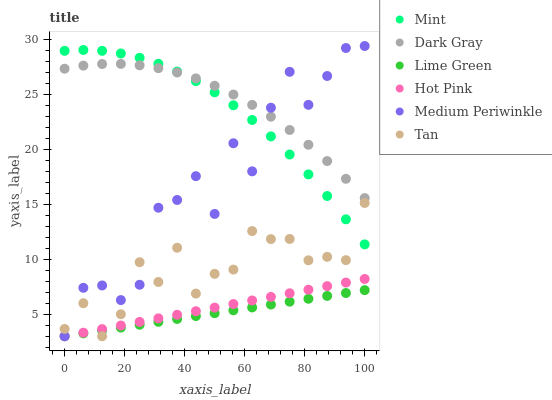Does Lime Green have the minimum area under the curve?
Answer yes or no. Yes. Does Dark Gray have the maximum area under the curve?
Answer yes or no. Yes. Does Hot Pink have the minimum area under the curve?
Answer yes or no. No. Does Hot Pink have the maximum area under the curve?
Answer yes or no. No. Is Hot Pink the smoothest?
Answer yes or no. Yes. Is Medium Periwinkle the roughest?
Answer yes or no. Yes. Is Medium Periwinkle the smoothest?
Answer yes or no. No. Is Hot Pink the roughest?
Answer yes or no. No. Does Hot Pink have the lowest value?
Answer yes or no. Yes. Does Dark Gray have the lowest value?
Answer yes or no. No. Does Medium Periwinkle have the highest value?
Answer yes or no. Yes. Does Hot Pink have the highest value?
Answer yes or no. No. Is Lime Green less than Mint?
Answer yes or no. Yes. Is Mint greater than Lime Green?
Answer yes or no. Yes. Does Lime Green intersect Tan?
Answer yes or no. Yes. Is Lime Green less than Tan?
Answer yes or no. No. Is Lime Green greater than Tan?
Answer yes or no. No. Does Lime Green intersect Mint?
Answer yes or no. No. 